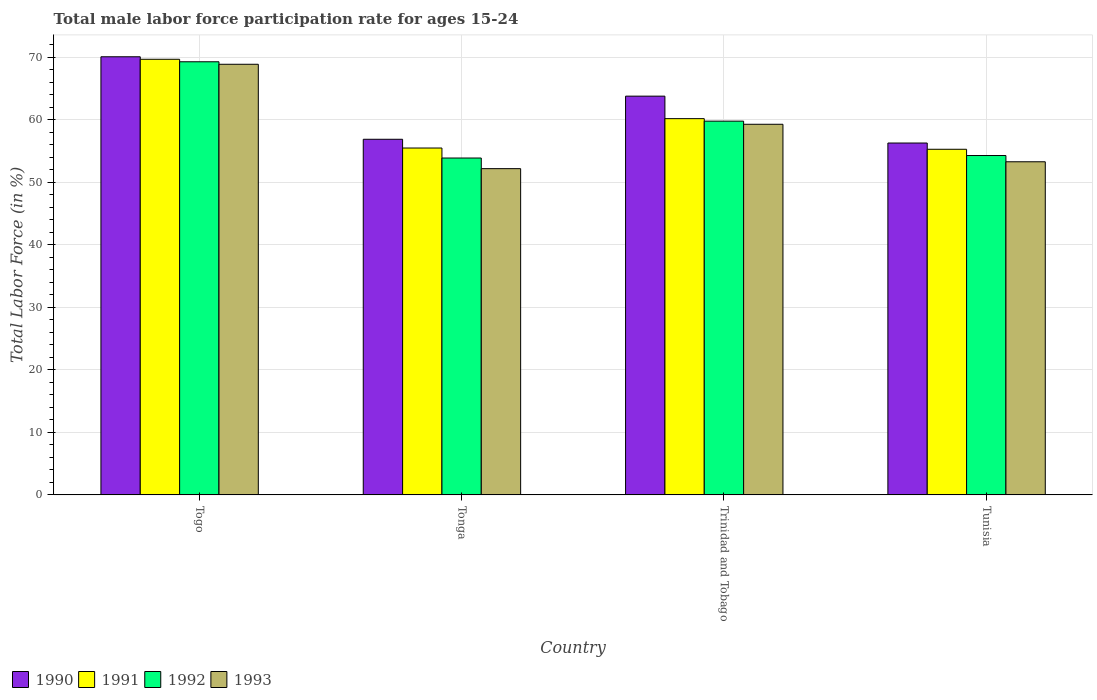How many different coloured bars are there?
Keep it short and to the point. 4. How many groups of bars are there?
Your response must be concise. 4. Are the number of bars per tick equal to the number of legend labels?
Give a very brief answer. Yes. Are the number of bars on each tick of the X-axis equal?
Provide a short and direct response. Yes. How many bars are there on the 4th tick from the left?
Keep it short and to the point. 4. How many bars are there on the 3rd tick from the right?
Your response must be concise. 4. What is the label of the 3rd group of bars from the left?
Ensure brevity in your answer.  Trinidad and Tobago. In how many cases, is the number of bars for a given country not equal to the number of legend labels?
Provide a short and direct response. 0. What is the male labor force participation rate in 1991 in Trinidad and Tobago?
Make the answer very short. 60.2. Across all countries, what is the maximum male labor force participation rate in 1992?
Give a very brief answer. 69.3. Across all countries, what is the minimum male labor force participation rate in 1992?
Keep it short and to the point. 53.9. In which country was the male labor force participation rate in 1990 maximum?
Ensure brevity in your answer.  Togo. In which country was the male labor force participation rate in 1991 minimum?
Your answer should be compact. Tunisia. What is the total male labor force participation rate in 1992 in the graph?
Offer a terse response. 237.3. What is the difference between the male labor force participation rate in 1993 in Togo and that in Tonga?
Your answer should be very brief. 16.7. What is the difference between the male labor force participation rate in 1990 in Togo and the male labor force participation rate in 1992 in Tonga?
Provide a short and direct response. 16.2. What is the average male labor force participation rate in 1993 per country?
Ensure brevity in your answer.  58.43. What is the difference between the male labor force participation rate of/in 1991 and male labor force participation rate of/in 1992 in Togo?
Provide a short and direct response. 0.4. In how many countries, is the male labor force participation rate in 1992 greater than 62 %?
Provide a short and direct response. 1. What is the ratio of the male labor force participation rate in 1992 in Tonga to that in Tunisia?
Give a very brief answer. 0.99. What is the difference between the highest and the second highest male labor force participation rate in 1991?
Your answer should be compact. -9.5. What is the difference between the highest and the lowest male labor force participation rate in 1992?
Your answer should be compact. 15.4. In how many countries, is the male labor force participation rate in 1993 greater than the average male labor force participation rate in 1993 taken over all countries?
Ensure brevity in your answer.  2. What does the 2nd bar from the left in Togo represents?
Provide a short and direct response. 1991. Is it the case that in every country, the sum of the male labor force participation rate in 1992 and male labor force participation rate in 1993 is greater than the male labor force participation rate in 1991?
Your answer should be compact. Yes. Are all the bars in the graph horizontal?
Your answer should be compact. No. How many countries are there in the graph?
Make the answer very short. 4. What is the difference between two consecutive major ticks on the Y-axis?
Keep it short and to the point. 10. Are the values on the major ticks of Y-axis written in scientific E-notation?
Your answer should be compact. No. Does the graph contain any zero values?
Your answer should be very brief. No. Does the graph contain grids?
Give a very brief answer. Yes. How are the legend labels stacked?
Make the answer very short. Horizontal. What is the title of the graph?
Keep it short and to the point. Total male labor force participation rate for ages 15-24. Does "1982" appear as one of the legend labels in the graph?
Offer a terse response. No. What is the label or title of the X-axis?
Your response must be concise. Country. What is the Total Labor Force (in %) of 1990 in Togo?
Ensure brevity in your answer.  70.1. What is the Total Labor Force (in %) in 1991 in Togo?
Your answer should be compact. 69.7. What is the Total Labor Force (in %) of 1992 in Togo?
Make the answer very short. 69.3. What is the Total Labor Force (in %) in 1993 in Togo?
Offer a very short reply. 68.9. What is the Total Labor Force (in %) in 1990 in Tonga?
Ensure brevity in your answer.  56.9. What is the Total Labor Force (in %) in 1991 in Tonga?
Provide a short and direct response. 55.5. What is the Total Labor Force (in %) in 1992 in Tonga?
Your answer should be very brief. 53.9. What is the Total Labor Force (in %) in 1993 in Tonga?
Provide a short and direct response. 52.2. What is the Total Labor Force (in %) of 1990 in Trinidad and Tobago?
Make the answer very short. 63.8. What is the Total Labor Force (in %) of 1991 in Trinidad and Tobago?
Keep it short and to the point. 60.2. What is the Total Labor Force (in %) in 1992 in Trinidad and Tobago?
Offer a very short reply. 59.8. What is the Total Labor Force (in %) in 1993 in Trinidad and Tobago?
Your answer should be very brief. 59.3. What is the Total Labor Force (in %) in 1990 in Tunisia?
Your answer should be compact. 56.3. What is the Total Labor Force (in %) in 1991 in Tunisia?
Provide a succinct answer. 55.3. What is the Total Labor Force (in %) of 1992 in Tunisia?
Offer a terse response. 54.3. What is the Total Labor Force (in %) in 1993 in Tunisia?
Give a very brief answer. 53.3. Across all countries, what is the maximum Total Labor Force (in %) in 1990?
Keep it short and to the point. 70.1. Across all countries, what is the maximum Total Labor Force (in %) in 1991?
Give a very brief answer. 69.7. Across all countries, what is the maximum Total Labor Force (in %) of 1992?
Keep it short and to the point. 69.3. Across all countries, what is the maximum Total Labor Force (in %) in 1993?
Offer a terse response. 68.9. Across all countries, what is the minimum Total Labor Force (in %) in 1990?
Your answer should be very brief. 56.3. Across all countries, what is the minimum Total Labor Force (in %) in 1991?
Ensure brevity in your answer.  55.3. Across all countries, what is the minimum Total Labor Force (in %) in 1992?
Ensure brevity in your answer.  53.9. Across all countries, what is the minimum Total Labor Force (in %) of 1993?
Your response must be concise. 52.2. What is the total Total Labor Force (in %) of 1990 in the graph?
Ensure brevity in your answer.  247.1. What is the total Total Labor Force (in %) in 1991 in the graph?
Give a very brief answer. 240.7. What is the total Total Labor Force (in %) in 1992 in the graph?
Your response must be concise. 237.3. What is the total Total Labor Force (in %) in 1993 in the graph?
Your answer should be compact. 233.7. What is the difference between the Total Labor Force (in %) in 1993 in Togo and that in Tonga?
Provide a succinct answer. 16.7. What is the difference between the Total Labor Force (in %) in 1990 in Togo and that in Trinidad and Tobago?
Make the answer very short. 6.3. What is the difference between the Total Labor Force (in %) in 1992 in Togo and that in Trinidad and Tobago?
Ensure brevity in your answer.  9.5. What is the difference between the Total Labor Force (in %) of 1991 in Togo and that in Tunisia?
Keep it short and to the point. 14.4. What is the difference between the Total Labor Force (in %) of 1992 in Togo and that in Tunisia?
Make the answer very short. 15. What is the difference between the Total Labor Force (in %) in 1993 in Togo and that in Tunisia?
Provide a succinct answer. 15.6. What is the difference between the Total Labor Force (in %) in 1990 in Tonga and that in Trinidad and Tobago?
Provide a succinct answer. -6.9. What is the difference between the Total Labor Force (in %) of 1990 in Tonga and that in Tunisia?
Your response must be concise. 0.6. What is the difference between the Total Labor Force (in %) in 1991 in Tonga and that in Tunisia?
Provide a short and direct response. 0.2. What is the difference between the Total Labor Force (in %) in 1992 in Tonga and that in Tunisia?
Give a very brief answer. -0.4. What is the difference between the Total Labor Force (in %) in 1993 in Tonga and that in Tunisia?
Provide a short and direct response. -1.1. What is the difference between the Total Labor Force (in %) of 1991 in Trinidad and Tobago and that in Tunisia?
Give a very brief answer. 4.9. What is the difference between the Total Labor Force (in %) of 1993 in Trinidad and Tobago and that in Tunisia?
Keep it short and to the point. 6. What is the difference between the Total Labor Force (in %) in 1990 in Togo and the Total Labor Force (in %) in 1991 in Tonga?
Offer a terse response. 14.6. What is the difference between the Total Labor Force (in %) in 1991 in Togo and the Total Labor Force (in %) in 1993 in Tonga?
Your answer should be compact. 17.5. What is the difference between the Total Labor Force (in %) of 1992 in Togo and the Total Labor Force (in %) of 1993 in Tonga?
Your answer should be compact. 17.1. What is the difference between the Total Labor Force (in %) of 1990 in Togo and the Total Labor Force (in %) of 1993 in Trinidad and Tobago?
Your answer should be very brief. 10.8. What is the difference between the Total Labor Force (in %) in 1991 in Togo and the Total Labor Force (in %) in 1992 in Trinidad and Tobago?
Your answer should be compact. 9.9. What is the difference between the Total Labor Force (in %) in 1991 in Togo and the Total Labor Force (in %) in 1993 in Trinidad and Tobago?
Offer a terse response. 10.4. What is the difference between the Total Labor Force (in %) of 1991 in Togo and the Total Labor Force (in %) of 1993 in Tunisia?
Provide a succinct answer. 16.4. What is the difference between the Total Labor Force (in %) in 1991 in Tonga and the Total Labor Force (in %) in 1992 in Trinidad and Tobago?
Give a very brief answer. -4.3. What is the difference between the Total Labor Force (in %) of 1990 in Tonga and the Total Labor Force (in %) of 1993 in Tunisia?
Your answer should be very brief. 3.6. What is the difference between the Total Labor Force (in %) of 1990 in Trinidad and Tobago and the Total Labor Force (in %) of 1991 in Tunisia?
Offer a very short reply. 8.5. What is the difference between the Total Labor Force (in %) in 1990 in Trinidad and Tobago and the Total Labor Force (in %) in 1992 in Tunisia?
Keep it short and to the point. 9.5. What is the difference between the Total Labor Force (in %) in 1990 in Trinidad and Tobago and the Total Labor Force (in %) in 1993 in Tunisia?
Provide a succinct answer. 10.5. What is the difference between the Total Labor Force (in %) in 1991 in Trinidad and Tobago and the Total Labor Force (in %) in 1992 in Tunisia?
Make the answer very short. 5.9. What is the difference between the Total Labor Force (in %) of 1992 in Trinidad and Tobago and the Total Labor Force (in %) of 1993 in Tunisia?
Your response must be concise. 6.5. What is the average Total Labor Force (in %) in 1990 per country?
Provide a succinct answer. 61.77. What is the average Total Labor Force (in %) in 1991 per country?
Offer a terse response. 60.17. What is the average Total Labor Force (in %) of 1992 per country?
Keep it short and to the point. 59.33. What is the average Total Labor Force (in %) in 1993 per country?
Provide a short and direct response. 58.42. What is the difference between the Total Labor Force (in %) in 1990 and Total Labor Force (in %) in 1991 in Togo?
Provide a succinct answer. 0.4. What is the difference between the Total Labor Force (in %) of 1990 and Total Labor Force (in %) of 1992 in Togo?
Your answer should be compact. 0.8. What is the difference between the Total Labor Force (in %) in 1990 and Total Labor Force (in %) in 1993 in Togo?
Your answer should be compact. 1.2. What is the difference between the Total Labor Force (in %) in 1990 and Total Labor Force (in %) in 1993 in Tonga?
Provide a short and direct response. 4.7. What is the difference between the Total Labor Force (in %) in 1990 and Total Labor Force (in %) in 1992 in Trinidad and Tobago?
Give a very brief answer. 4. What is the difference between the Total Labor Force (in %) of 1990 and Total Labor Force (in %) of 1991 in Tunisia?
Your answer should be very brief. 1. What is the difference between the Total Labor Force (in %) in 1990 and Total Labor Force (in %) in 1993 in Tunisia?
Give a very brief answer. 3. What is the difference between the Total Labor Force (in %) of 1991 and Total Labor Force (in %) of 1992 in Tunisia?
Your answer should be very brief. 1. What is the difference between the Total Labor Force (in %) of 1991 and Total Labor Force (in %) of 1993 in Tunisia?
Offer a very short reply. 2. What is the ratio of the Total Labor Force (in %) of 1990 in Togo to that in Tonga?
Make the answer very short. 1.23. What is the ratio of the Total Labor Force (in %) in 1991 in Togo to that in Tonga?
Keep it short and to the point. 1.26. What is the ratio of the Total Labor Force (in %) in 1993 in Togo to that in Tonga?
Offer a very short reply. 1.32. What is the ratio of the Total Labor Force (in %) in 1990 in Togo to that in Trinidad and Tobago?
Your answer should be very brief. 1.1. What is the ratio of the Total Labor Force (in %) of 1991 in Togo to that in Trinidad and Tobago?
Provide a succinct answer. 1.16. What is the ratio of the Total Labor Force (in %) of 1992 in Togo to that in Trinidad and Tobago?
Ensure brevity in your answer.  1.16. What is the ratio of the Total Labor Force (in %) in 1993 in Togo to that in Trinidad and Tobago?
Give a very brief answer. 1.16. What is the ratio of the Total Labor Force (in %) of 1990 in Togo to that in Tunisia?
Keep it short and to the point. 1.25. What is the ratio of the Total Labor Force (in %) in 1991 in Togo to that in Tunisia?
Give a very brief answer. 1.26. What is the ratio of the Total Labor Force (in %) in 1992 in Togo to that in Tunisia?
Your answer should be very brief. 1.28. What is the ratio of the Total Labor Force (in %) of 1993 in Togo to that in Tunisia?
Offer a very short reply. 1.29. What is the ratio of the Total Labor Force (in %) in 1990 in Tonga to that in Trinidad and Tobago?
Ensure brevity in your answer.  0.89. What is the ratio of the Total Labor Force (in %) in 1991 in Tonga to that in Trinidad and Tobago?
Provide a short and direct response. 0.92. What is the ratio of the Total Labor Force (in %) of 1992 in Tonga to that in Trinidad and Tobago?
Keep it short and to the point. 0.9. What is the ratio of the Total Labor Force (in %) of 1993 in Tonga to that in Trinidad and Tobago?
Make the answer very short. 0.88. What is the ratio of the Total Labor Force (in %) in 1990 in Tonga to that in Tunisia?
Your answer should be very brief. 1.01. What is the ratio of the Total Labor Force (in %) of 1993 in Tonga to that in Tunisia?
Your answer should be very brief. 0.98. What is the ratio of the Total Labor Force (in %) in 1990 in Trinidad and Tobago to that in Tunisia?
Your answer should be compact. 1.13. What is the ratio of the Total Labor Force (in %) in 1991 in Trinidad and Tobago to that in Tunisia?
Your answer should be very brief. 1.09. What is the ratio of the Total Labor Force (in %) in 1992 in Trinidad and Tobago to that in Tunisia?
Your answer should be very brief. 1.1. What is the ratio of the Total Labor Force (in %) in 1993 in Trinidad and Tobago to that in Tunisia?
Offer a terse response. 1.11. What is the difference between the highest and the second highest Total Labor Force (in %) of 1991?
Keep it short and to the point. 9.5. What is the difference between the highest and the second highest Total Labor Force (in %) of 1992?
Provide a short and direct response. 9.5. What is the difference between the highest and the second highest Total Labor Force (in %) in 1993?
Offer a very short reply. 9.6. What is the difference between the highest and the lowest Total Labor Force (in %) in 1990?
Give a very brief answer. 13.8. What is the difference between the highest and the lowest Total Labor Force (in %) in 1991?
Offer a very short reply. 14.4. What is the difference between the highest and the lowest Total Labor Force (in %) in 1993?
Keep it short and to the point. 16.7. 